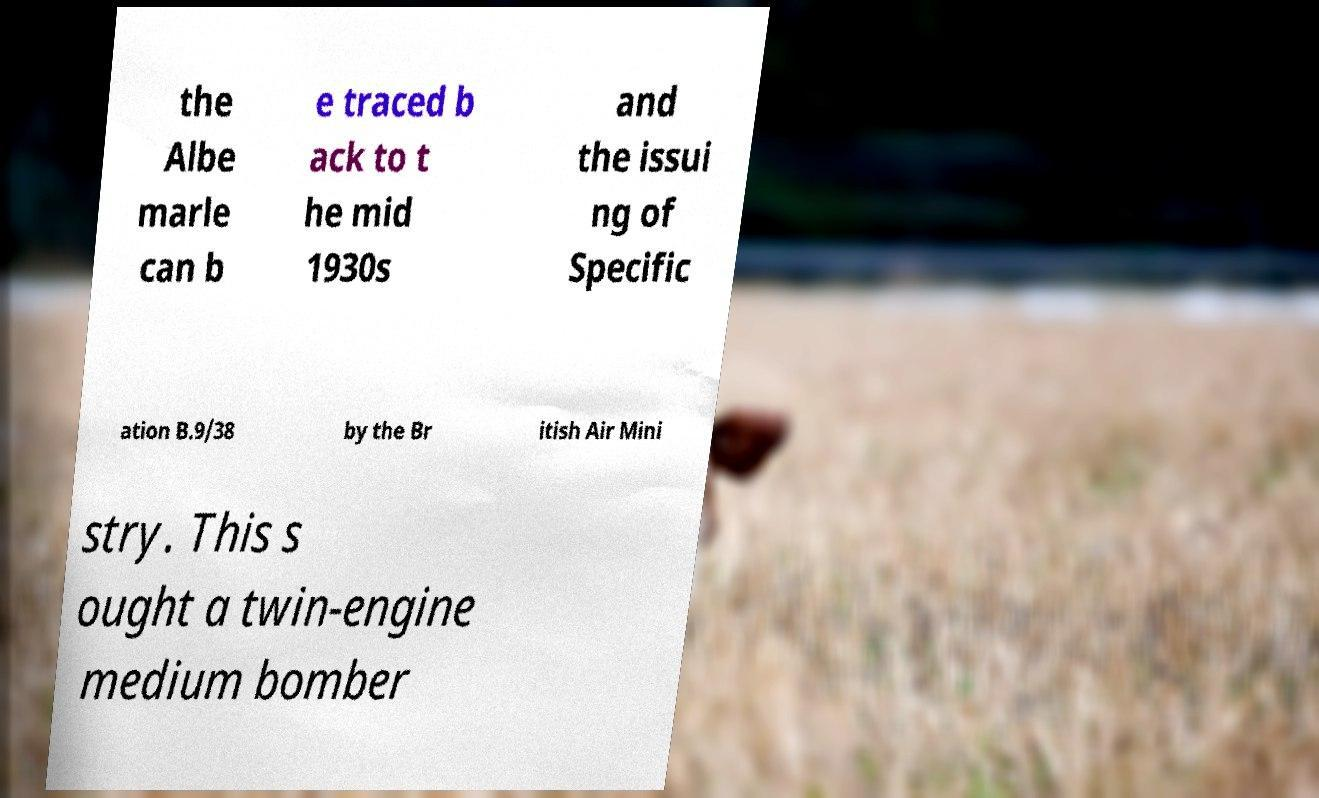Can you accurately transcribe the text from the provided image for me? the Albe marle can b e traced b ack to t he mid 1930s and the issui ng of Specific ation B.9/38 by the Br itish Air Mini stry. This s ought a twin-engine medium bomber 